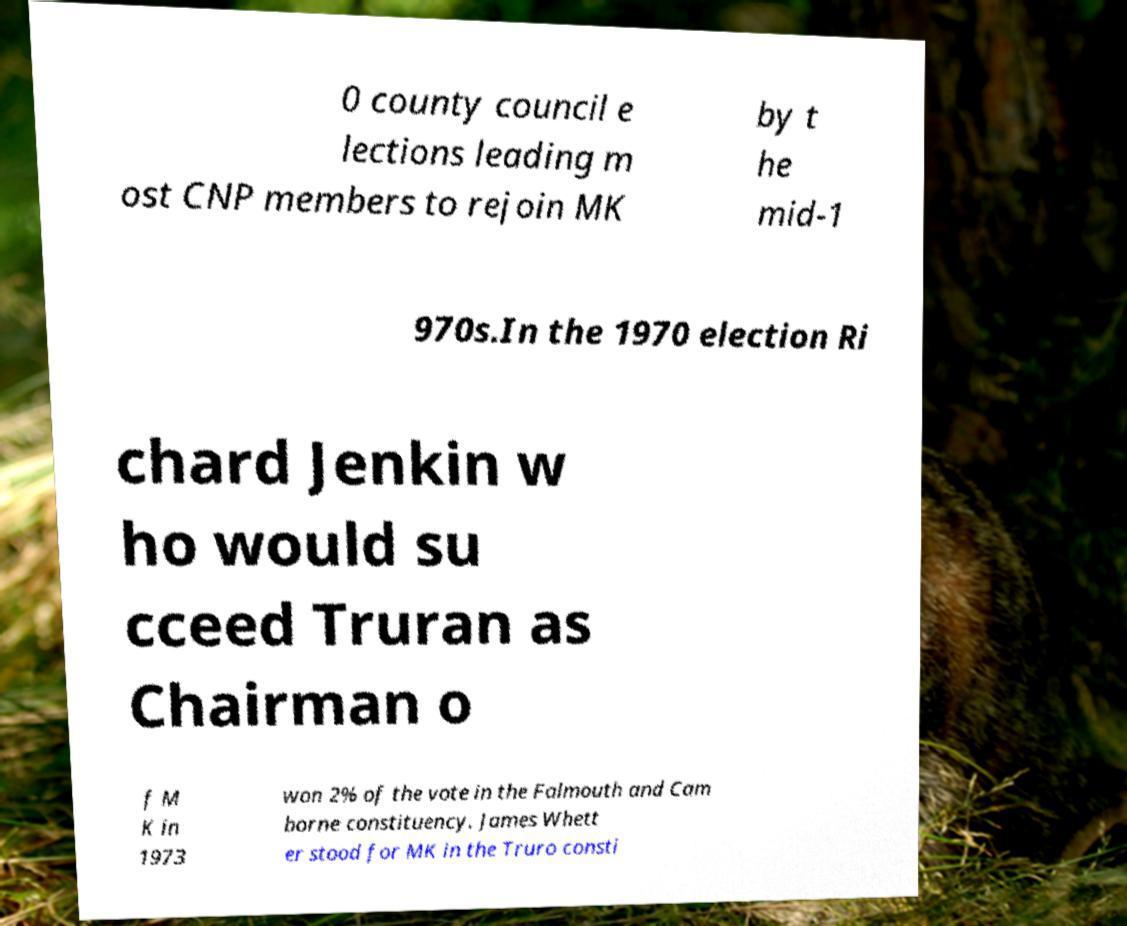Please read and relay the text visible in this image. What does it say? 0 county council e lections leading m ost CNP members to rejoin MK by t he mid-1 970s.In the 1970 election Ri chard Jenkin w ho would su cceed Truran as Chairman o f M K in 1973 won 2% of the vote in the Falmouth and Cam borne constituency. James Whett er stood for MK in the Truro consti 